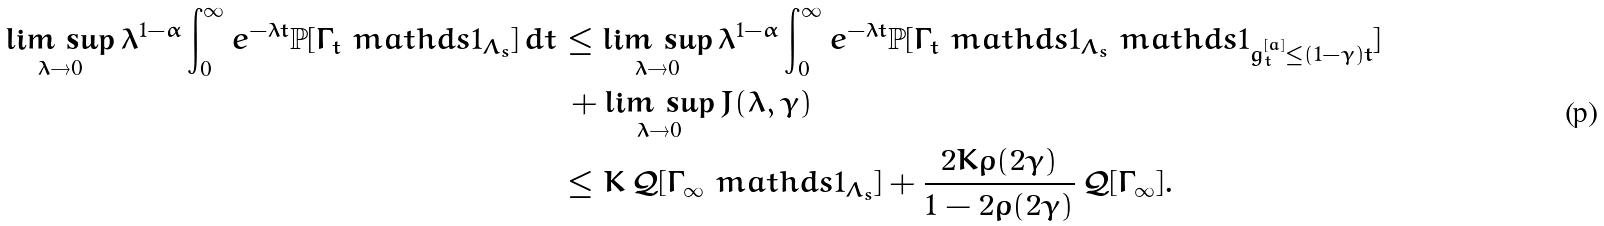Convert formula to latex. <formula><loc_0><loc_0><loc_500><loc_500>\underset { \lambda \rightarrow 0 } { \lim \, \sup } \, \lambda ^ { 1 - \alpha } \int _ { 0 } ^ { \infty } e ^ { - \lambda t } \mathbb { P } [ \Gamma _ { t } \ m a t h d s { 1 } _ { \Lambda _ { s } } ] \, d t & \leq \underset { \lambda \rightarrow 0 } { \lim \, \sup } \, \lambda ^ { 1 - \alpha } \int _ { 0 } ^ { \infty } e ^ { - \lambda t } \mathbb { P } [ \Gamma _ { t } \ m a t h d s { 1 } _ { \Lambda _ { s } } \ m a t h d s { 1 } _ { g _ { t } ^ { [ a ] } \leq ( 1 - \gamma ) t } ] \\ & \, + \underset { \lambda \rightarrow 0 } { \lim \, \sup } \, J ( \lambda , \gamma ) \\ & \leq K \, \mathcal { Q } [ \Gamma _ { \infty } \ m a t h d s { 1 } _ { \Lambda _ { s } } ] + \frac { 2 K \rho ( 2 \gamma ) } { 1 - 2 \rho ( 2 \gamma ) } \, \mathcal { Q } [ \Gamma _ { \infty } ] .</formula> 